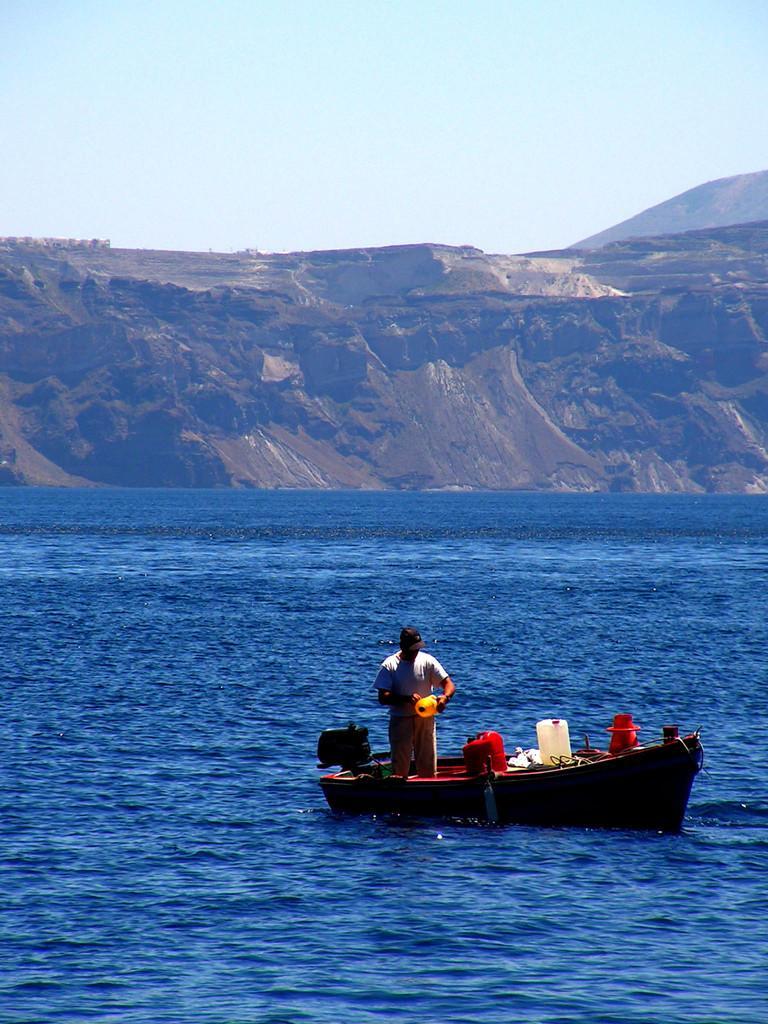Describe this image in one or two sentences. In this image, we can see a person on the boat which is floating on the water. There is a hill in the middle of the image. There is a sky at the top of the image. 